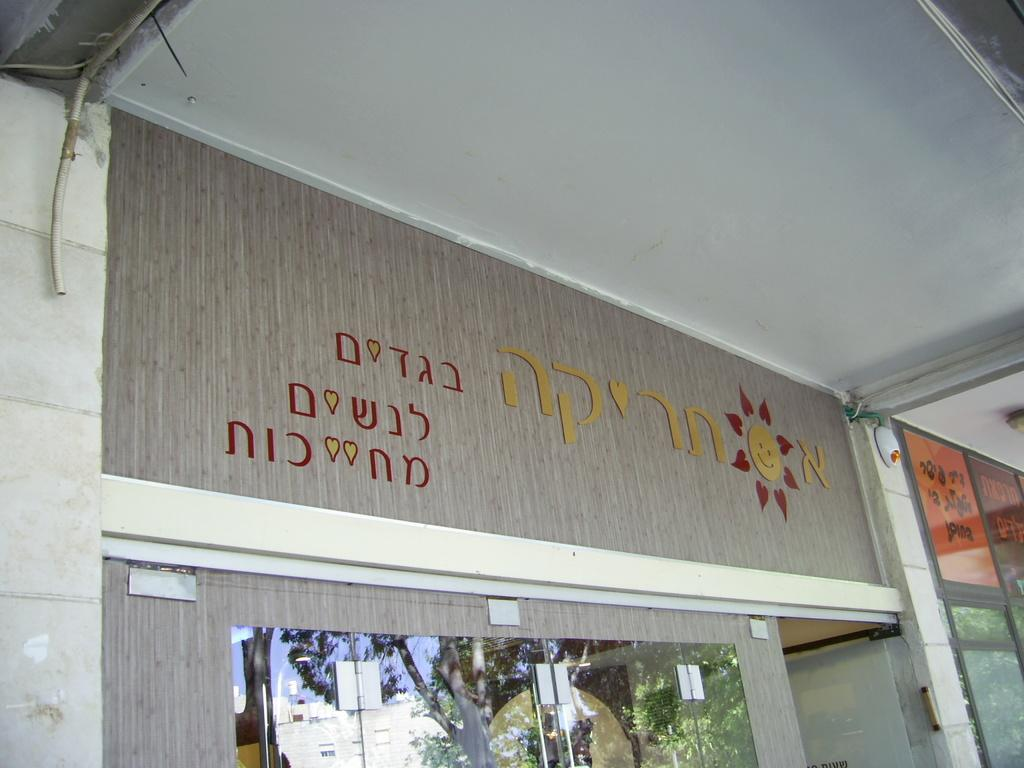What type of structures can be seen in the image? There are walls in the image. What other elements are present in the image? There are pipelines and windows in the image. What type of vegetation is visible in the image? There are trees in the image. What time of day is it in the image, given the presence of a field and a morning atmosphere? There is no field or indication of a specific time of day in the image. The image only shows walls, pipelines, windows, and trees. 